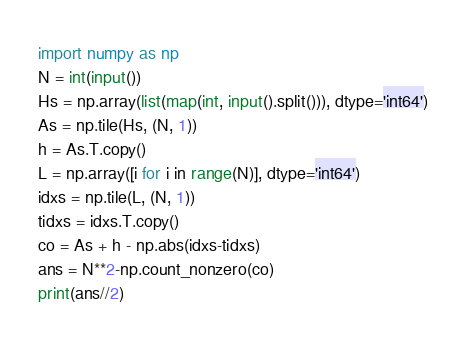Convert code to text. <code><loc_0><loc_0><loc_500><loc_500><_Python_>import numpy as np
N = int(input())
Hs = np.array(list(map(int, input().split())), dtype='int64')
As = np.tile(Hs, (N, 1))
h = As.T.copy()
L = np.array([i for i in range(N)], dtype='int64')
idxs = np.tile(L, (N, 1))
tidxs = idxs.T.copy()
co = As + h - np.abs(idxs-tidxs)
ans = N**2-np.count_nonzero(co)
print(ans//2)</code> 